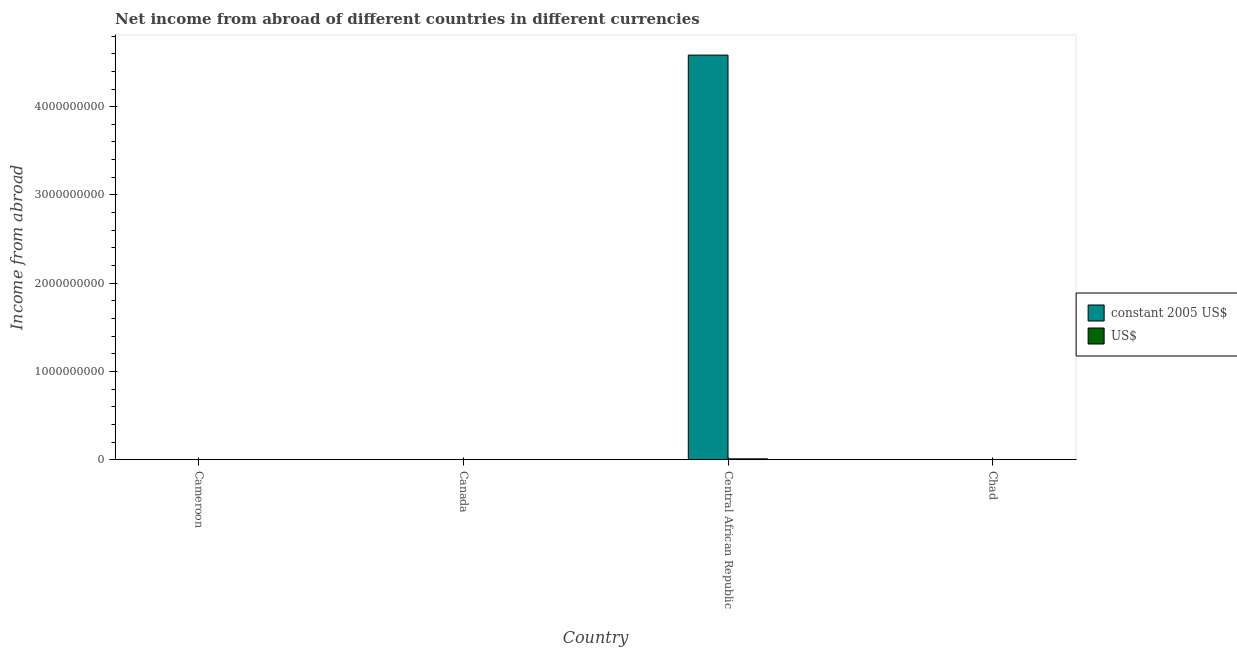Are the number of bars on each tick of the X-axis equal?
Your answer should be very brief. No. How many bars are there on the 4th tick from the left?
Keep it short and to the point. 0. Across all countries, what is the maximum income from abroad in constant 2005 us$?
Ensure brevity in your answer.  4.58e+09. Across all countries, what is the minimum income from abroad in us$?
Your answer should be very brief. 0. In which country was the income from abroad in us$ maximum?
Your response must be concise. Central African Republic. What is the total income from abroad in us$ in the graph?
Provide a short and direct response. 9.72e+06. What is the difference between the income from abroad in us$ in Chad and the income from abroad in constant 2005 us$ in Cameroon?
Your response must be concise. 0. What is the average income from abroad in constant 2005 us$ per country?
Ensure brevity in your answer.  1.15e+09. What is the difference between the income from abroad in constant 2005 us$ and income from abroad in us$ in Central African Republic?
Your answer should be compact. 4.57e+09. In how many countries, is the income from abroad in constant 2005 us$ greater than 3000000000 units?
Your answer should be compact. 1. What is the difference between the highest and the lowest income from abroad in us$?
Keep it short and to the point. 9.72e+06. In how many countries, is the income from abroad in us$ greater than the average income from abroad in us$ taken over all countries?
Provide a short and direct response. 1. Are all the bars in the graph horizontal?
Make the answer very short. No. Are the values on the major ticks of Y-axis written in scientific E-notation?
Make the answer very short. No. Does the graph contain any zero values?
Ensure brevity in your answer.  Yes. What is the title of the graph?
Your answer should be compact. Net income from abroad of different countries in different currencies. What is the label or title of the X-axis?
Keep it short and to the point. Country. What is the label or title of the Y-axis?
Your response must be concise. Income from abroad. What is the Income from abroad in US$ in Cameroon?
Make the answer very short. 0. What is the Income from abroad of constant 2005 US$ in Canada?
Your response must be concise. 0. What is the Income from abroad of constant 2005 US$ in Central African Republic?
Provide a short and direct response. 4.58e+09. What is the Income from abroad of US$ in Central African Republic?
Provide a succinct answer. 9.72e+06. What is the Income from abroad in US$ in Chad?
Provide a succinct answer. 0. Across all countries, what is the maximum Income from abroad of constant 2005 US$?
Make the answer very short. 4.58e+09. Across all countries, what is the maximum Income from abroad in US$?
Make the answer very short. 9.72e+06. Across all countries, what is the minimum Income from abroad of constant 2005 US$?
Your response must be concise. 0. What is the total Income from abroad of constant 2005 US$ in the graph?
Make the answer very short. 4.58e+09. What is the total Income from abroad of US$ in the graph?
Keep it short and to the point. 9.72e+06. What is the average Income from abroad in constant 2005 US$ per country?
Ensure brevity in your answer.  1.15e+09. What is the average Income from abroad of US$ per country?
Keep it short and to the point. 2.43e+06. What is the difference between the Income from abroad of constant 2005 US$ and Income from abroad of US$ in Central African Republic?
Ensure brevity in your answer.  4.57e+09. What is the difference between the highest and the lowest Income from abroad in constant 2005 US$?
Your answer should be compact. 4.58e+09. What is the difference between the highest and the lowest Income from abroad of US$?
Ensure brevity in your answer.  9.72e+06. 